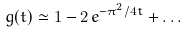Convert formula to latex. <formula><loc_0><loc_0><loc_500><loc_500>g ( t ) \simeq 1 - 2 \, e ^ { - \pi ^ { 2 } / { 4 t } } + \dots</formula> 